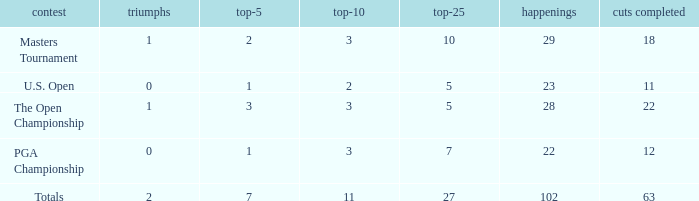How many top 10s associated with 3 top 5s and under 22 cuts made? None. Parse the full table. {'header': ['contest', 'triumphs', 'top-5', 'top-10', 'top-25', 'happenings', 'cuts completed'], 'rows': [['Masters Tournament', '1', '2', '3', '10', '29', '18'], ['U.S. Open', '0', '1', '2', '5', '23', '11'], ['The Open Championship', '1', '3', '3', '5', '28', '22'], ['PGA Championship', '0', '1', '3', '7', '22', '12'], ['Totals', '2', '7', '11', '27', '102', '63']]} 